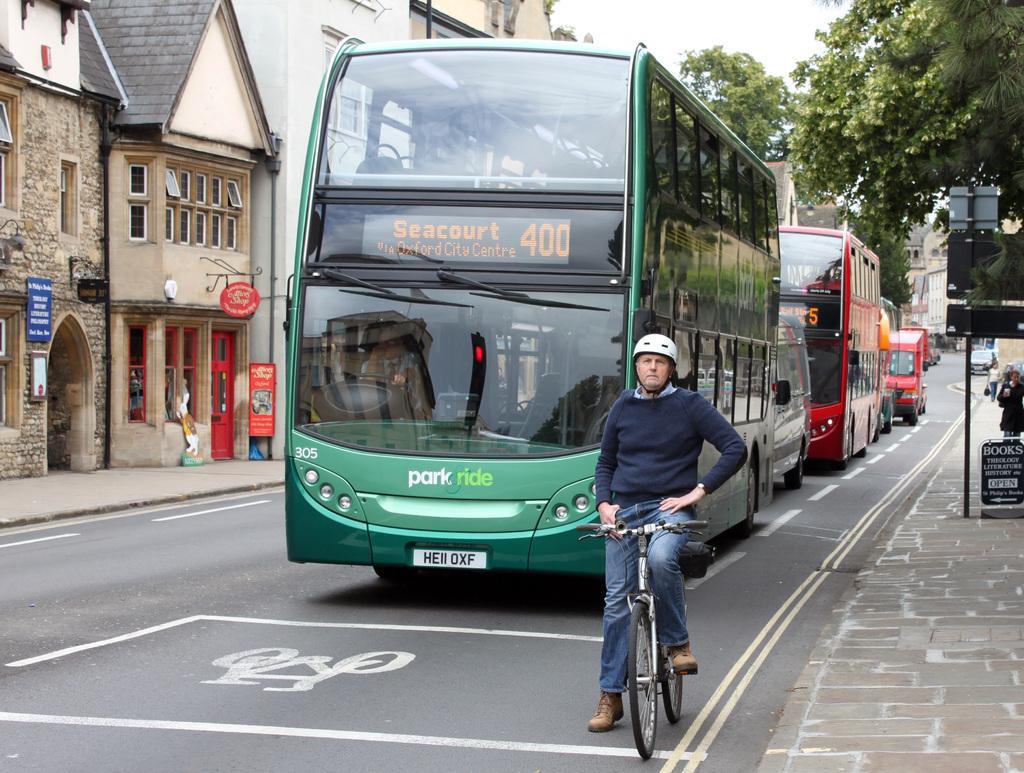Describe this image in one or two sentences. on the road there is a person sitting on the bicycle. behind him there are buses. at the right there are trees. at the left there are buildings. 